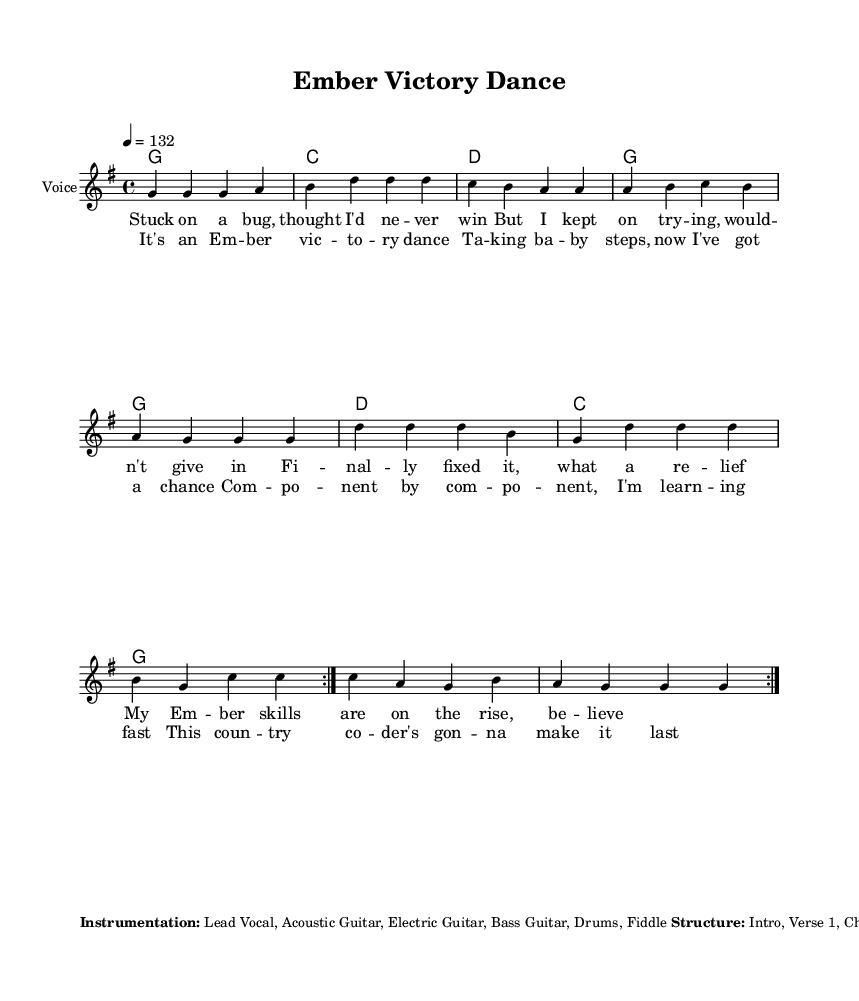What is the key signature of this music? The key signature is indicated at the beginning of the staff with one sharp, which identifies the music as being in G major.
Answer: G major What is the time signature of the piece? The time signature is located at the beginning of the staff and is noted as 4/4, meaning there are four beats in a measure and a quarter note gets one beat.
Answer: 4/4 What is the tempo marking for this song? The tempo marking is found at the beginning, noted as "4 = 132," indicating the number of beats per minute (BPM).
Answer: 132 What is the structure of the song? The structure is detailed in the markup section, listing sections such as Intro, Verse 1, Chorus, and so on, providing a clear guide on how the song progresses.
Answer: Intro, Verse 1, Chorus, Verse 2, Chorus, Bridge, Chorus, Outro How many times is the melody repeated in the piece? In the melody section, the instruction "\repeat volta 2" indicates that the melody is to be played twice before moving on.
Answer: 2 What instruments are included in the instrumentation? The instrumentation is noted in the markup, listing Lead Vocal, Acoustic Guitar, Electric Guitar, Bass Guitar, Drums, and Fiddle as part of the ensemble.
Answer: Lead Vocal, Acoustic Guitar, Electric Guitar, Bass Guitar, Drums, Fiddle What is the strumming pattern for the rhythm guitar? The strumming pattern is mentioned in the markup section, labeled as "D DU UDU," which describes the specific strumming technique for the rhythm guitar in the piece.
Answer: D DU UDU 